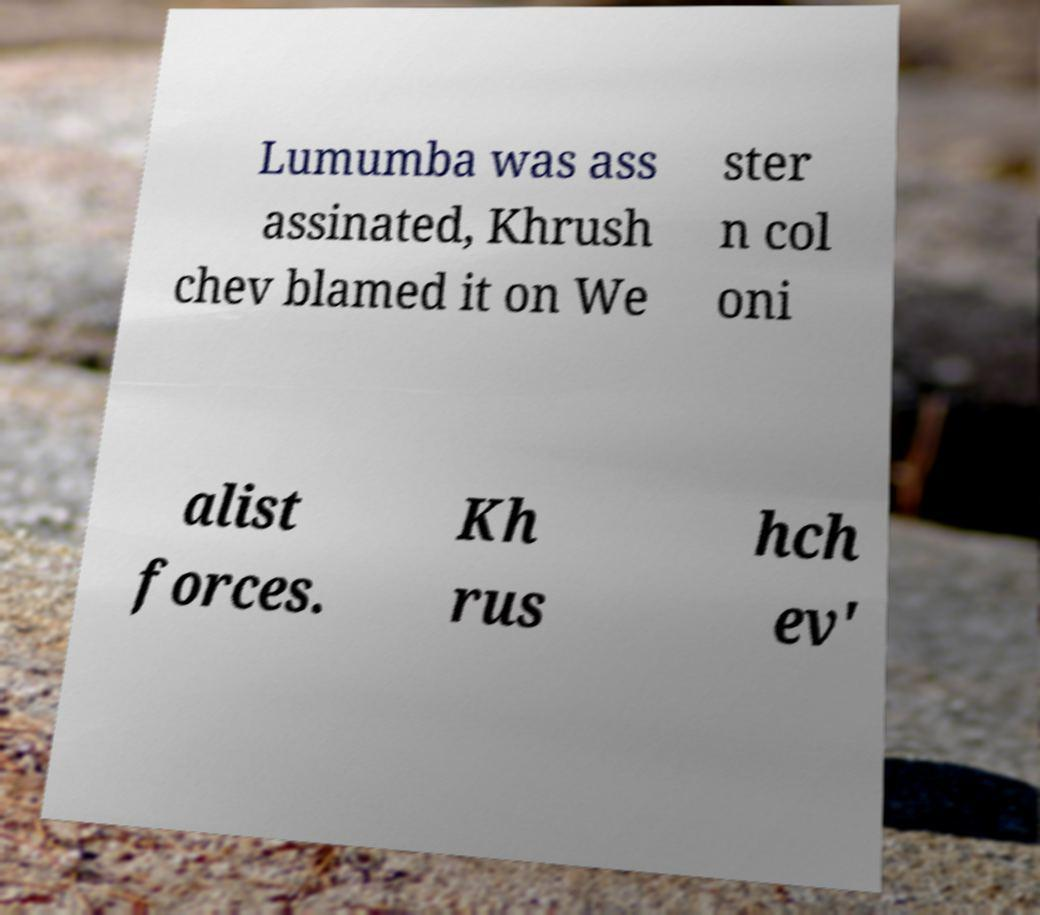What messages or text are displayed in this image? I need them in a readable, typed format. Lumumba was ass assinated, Khrush chev blamed it on We ster n col oni alist forces. Kh rus hch ev' 